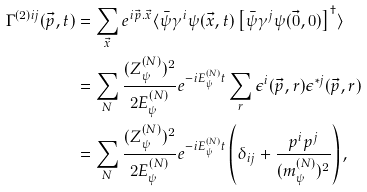Convert formula to latex. <formula><loc_0><loc_0><loc_500><loc_500>\Gamma ^ { ( 2 ) i j } ( \vec { p } , t ) & = \sum _ { \vec { x } } e ^ { i \vec { p } . \vec { x } } \langle \bar { \psi } \gamma ^ { i } \psi ( \vec { x } , t ) \left [ \bar { \psi } \gamma ^ { j } \psi ( \vec { 0 } , 0 ) \right ] ^ { \dag } \rangle \\ & = \sum _ { N } \frac { ( Z ^ { ( N ) } _ { \psi } ) ^ { 2 } } { 2 E ^ { ( N ) } _ { \psi } } e ^ { - i E ^ { ( N ) } _ { \psi } t } \sum _ { r } \epsilon ^ { i } ( \vec { p } , r ) \epsilon ^ { * j } ( \vec { p } , r ) \\ & = \sum _ { N } \frac { ( Z ^ { ( N ) } _ { \psi } ) ^ { 2 } } { 2 E ^ { ( N ) } _ { \psi } } e ^ { - i E ^ { ( N ) } _ { \psi } t } \left ( \delta _ { i j } + \frac { p ^ { i } p ^ { j } } { ( m ^ { ( N ) } _ { \psi } ) ^ { 2 } } \right ) ,</formula> 